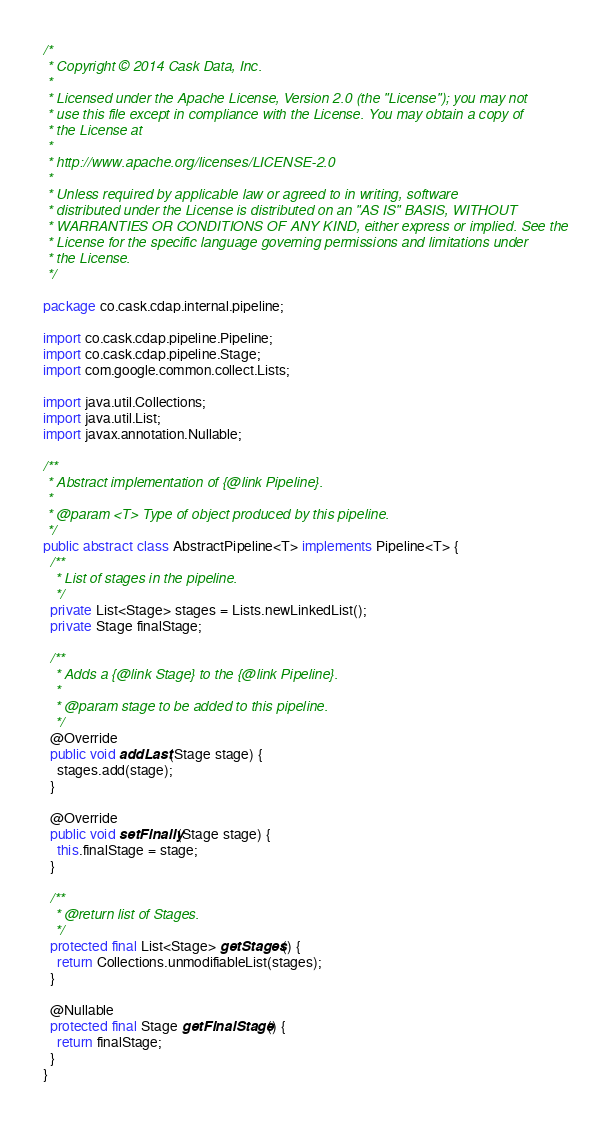<code> <loc_0><loc_0><loc_500><loc_500><_Java_>/*
 * Copyright © 2014 Cask Data, Inc.
 *
 * Licensed under the Apache License, Version 2.0 (the "License"); you may not
 * use this file except in compliance with the License. You may obtain a copy of
 * the License at
 *
 * http://www.apache.org/licenses/LICENSE-2.0
 *
 * Unless required by applicable law or agreed to in writing, software
 * distributed under the License is distributed on an "AS IS" BASIS, WITHOUT
 * WARRANTIES OR CONDITIONS OF ANY KIND, either express or implied. See the
 * License for the specific language governing permissions and limitations under
 * the License.
 */

package co.cask.cdap.internal.pipeline;

import co.cask.cdap.pipeline.Pipeline;
import co.cask.cdap.pipeline.Stage;
import com.google.common.collect.Lists;

import java.util.Collections;
import java.util.List;
import javax.annotation.Nullable;

/**
 * Abstract implementation of {@link Pipeline}.
 *
 * @param <T> Type of object produced by this pipeline.
 */
public abstract class AbstractPipeline<T> implements Pipeline<T> {
  /**
   * List of stages in the pipeline.
   */
  private List<Stage> stages = Lists.newLinkedList();
  private Stage finalStage;

  /**
   * Adds a {@link Stage} to the {@link Pipeline}.
   *
   * @param stage to be added to this pipeline.
   */
  @Override
  public void addLast(Stage stage) {
    stages.add(stage);
  }

  @Override
  public void setFinally(Stage stage) {
    this.finalStage = stage;
  }

  /**
   * @return list of Stages.
   */
  protected final List<Stage> getStages() {
    return Collections.unmodifiableList(stages);
  }

  @Nullable
  protected final Stage getFinalStage() {
    return finalStage;
  }
}
</code> 